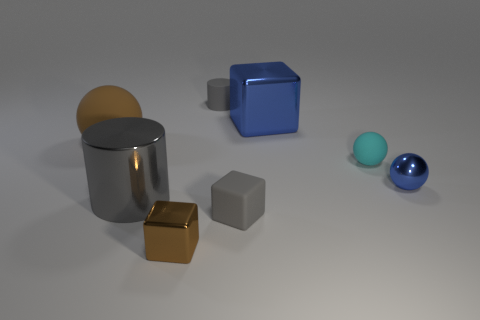Subtract all balls. How many objects are left? 5 Add 2 purple rubber things. How many objects exist? 10 Subtract all small green metallic objects. Subtract all brown spheres. How many objects are left? 7 Add 2 big gray metal things. How many big gray metal things are left? 3 Add 6 brown things. How many brown things exist? 8 Subtract 0 purple spheres. How many objects are left? 8 